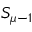<formula> <loc_0><loc_0><loc_500><loc_500>S _ { \mu - 1 }</formula> 